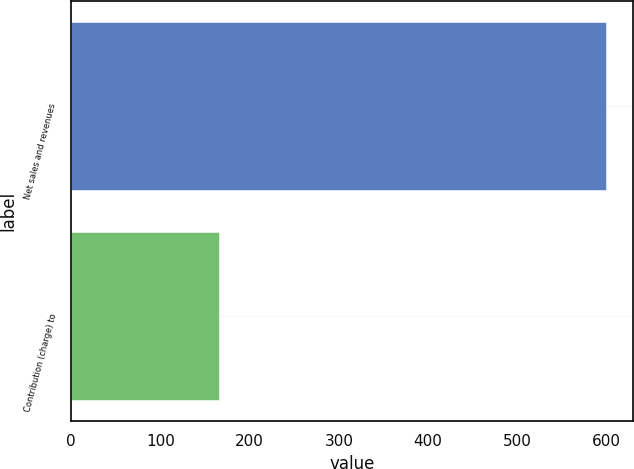Convert chart to OTSL. <chart><loc_0><loc_0><loc_500><loc_500><bar_chart><fcel>Net sales and revenues<fcel>Contribution (charge) to<nl><fcel>600<fcel>166<nl></chart> 